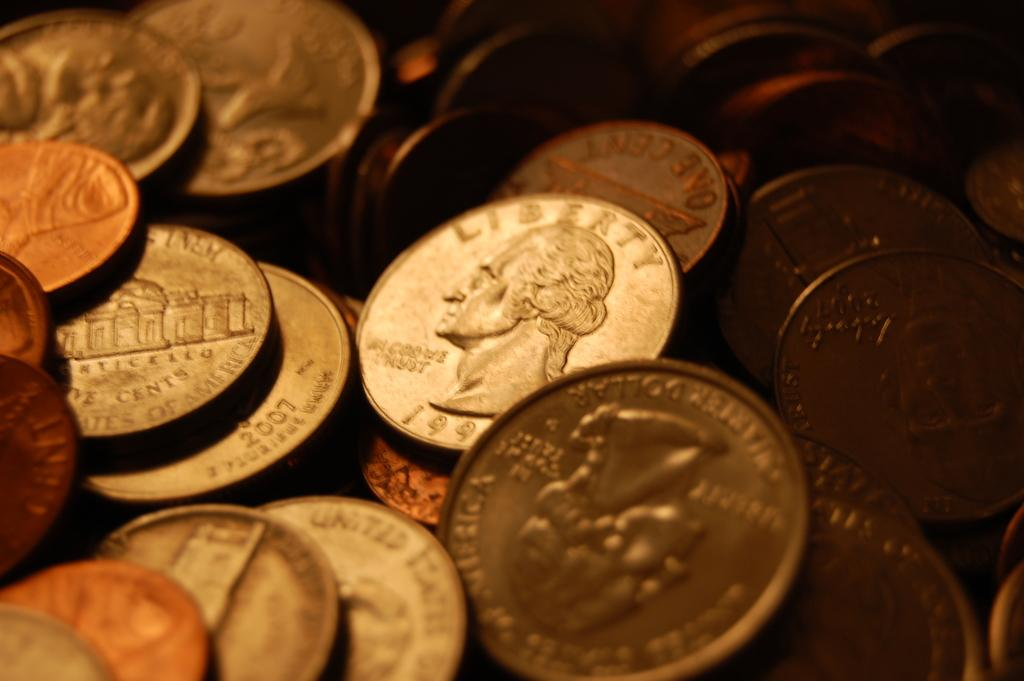Provide a one-sentence caption for the provided image. Coin showing a president's head and says Liberty above it. 